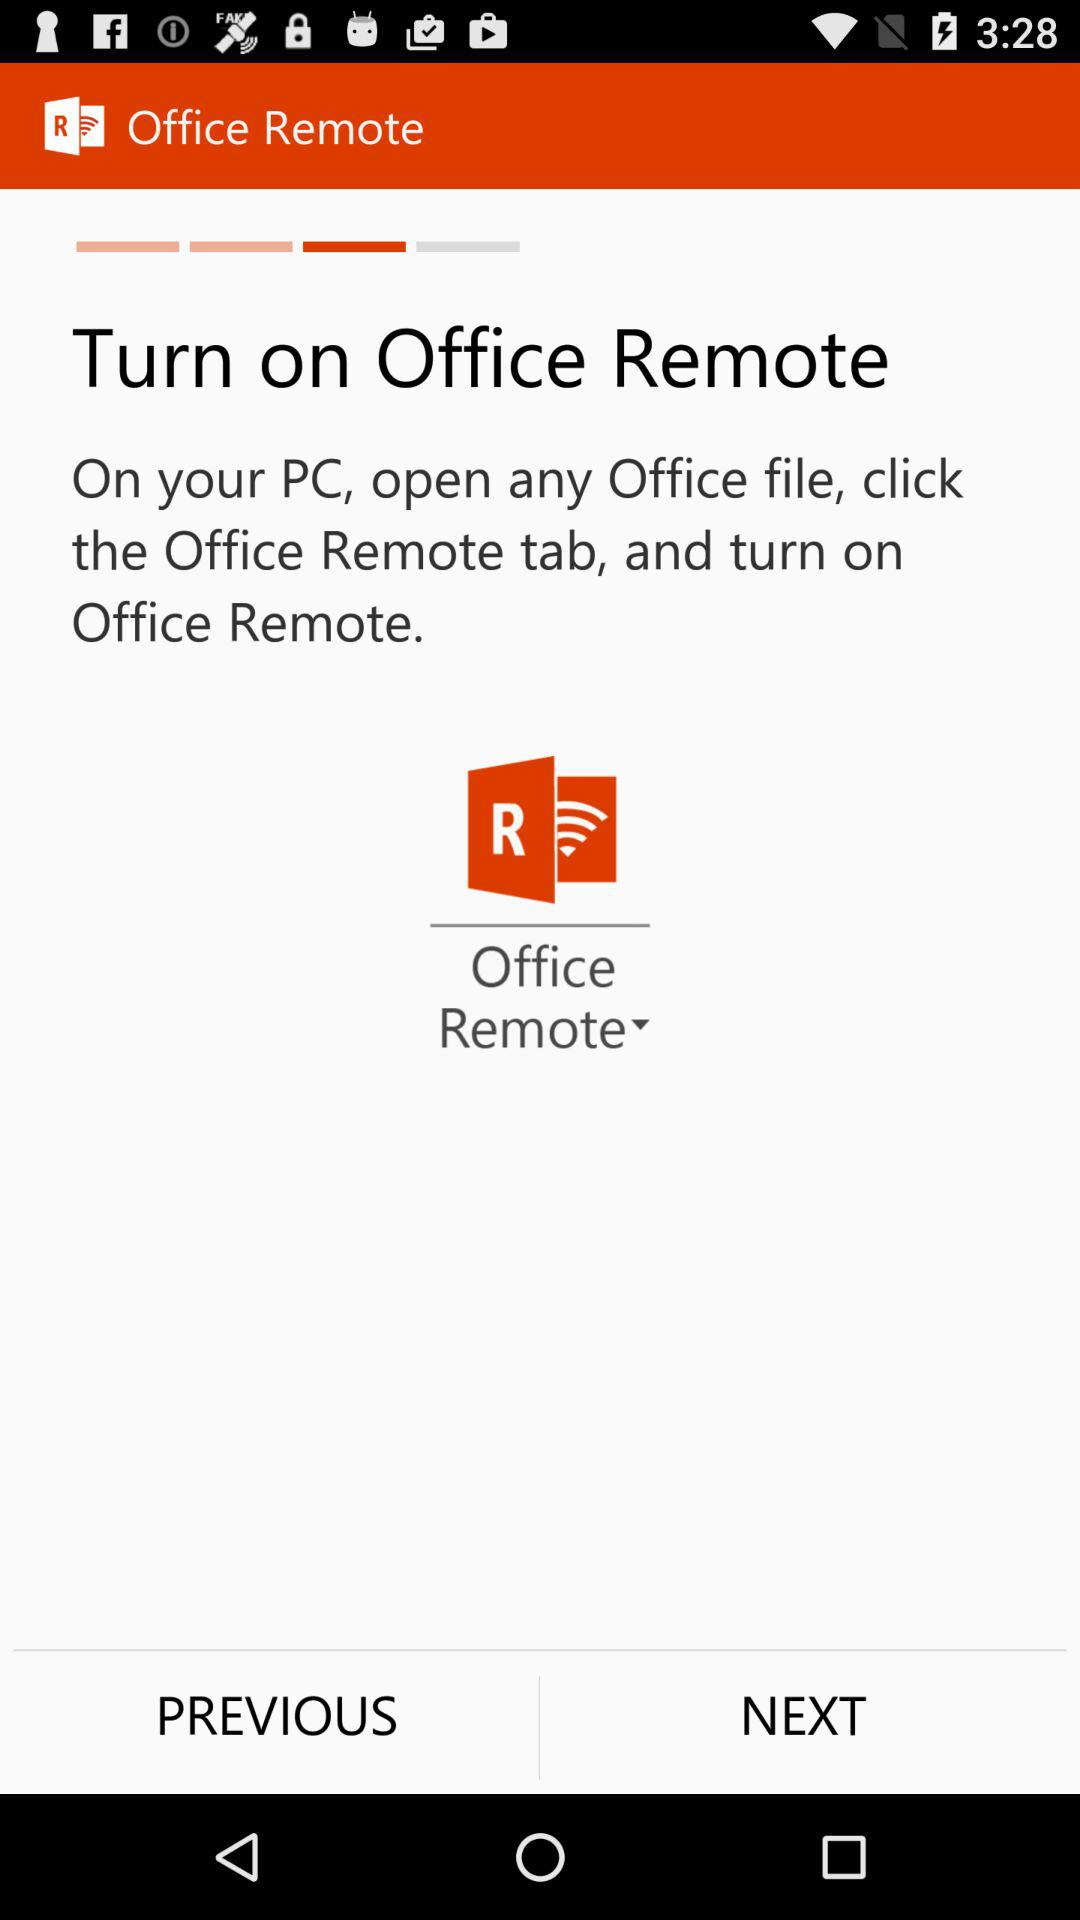What is the application name? The application name is "Office Remote". 